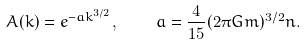<formula> <loc_0><loc_0><loc_500><loc_500>A ( { k } ) = e ^ { - a k ^ { 3 / 2 } } , \quad a = \frac { 4 } { 1 5 } ( 2 \pi G m ) ^ { 3 / 2 } n .</formula> 